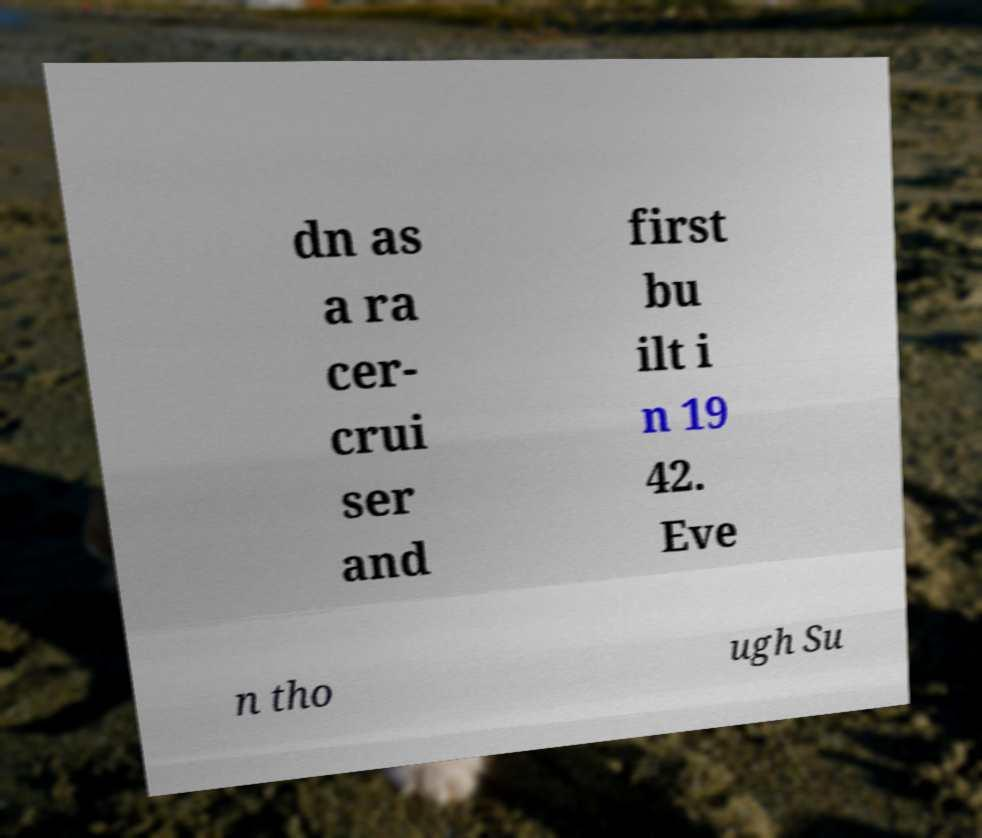For documentation purposes, I need the text within this image transcribed. Could you provide that? dn as a ra cer- crui ser and first bu ilt i n 19 42. Eve n tho ugh Su 